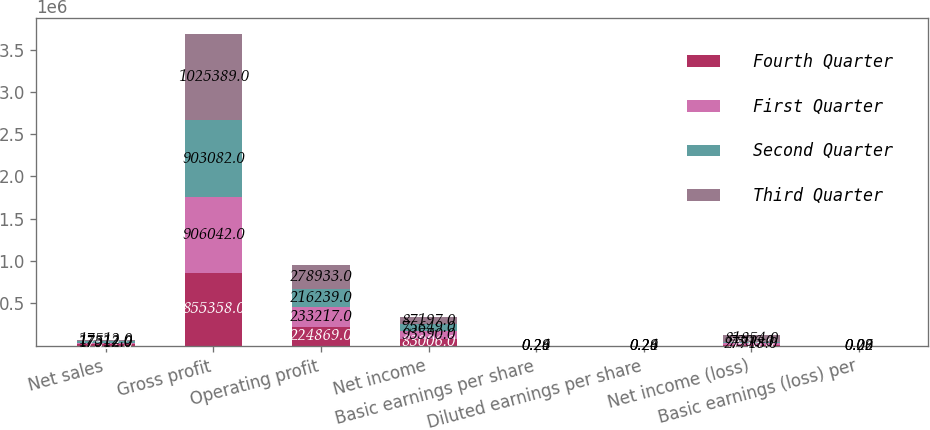<chart> <loc_0><loc_0><loc_500><loc_500><stacked_bar_chart><ecel><fcel>Net sales<fcel>Gross profit<fcel>Operating profit<fcel>Net income<fcel>Basic earnings per share<fcel>Diluted earnings per share<fcel>Net income (loss)<fcel>Basic earnings (loss) per<nl><fcel>Fourth Quarter<fcel>17512<fcel>855358<fcel>224869<fcel>83006<fcel>0.26<fcel>0.26<fcel>5916<fcel>0.02<nl><fcel>First Quarter<fcel>17512<fcel>906042<fcel>233217<fcel>93590<fcel>0.29<fcel>0.29<fcel>27718<fcel>0.09<nl><fcel>Second Quarter<fcel>17512<fcel>903082<fcel>216239<fcel>75649<fcel>0.24<fcel>0.24<fcel>7306<fcel>0.02<nl><fcel>Third Quarter<fcel>17512<fcel>1.02539e+06<fcel>278933<fcel>87197<fcel>0.26<fcel>0.26<fcel>81854<fcel>0.26<nl></chart> 